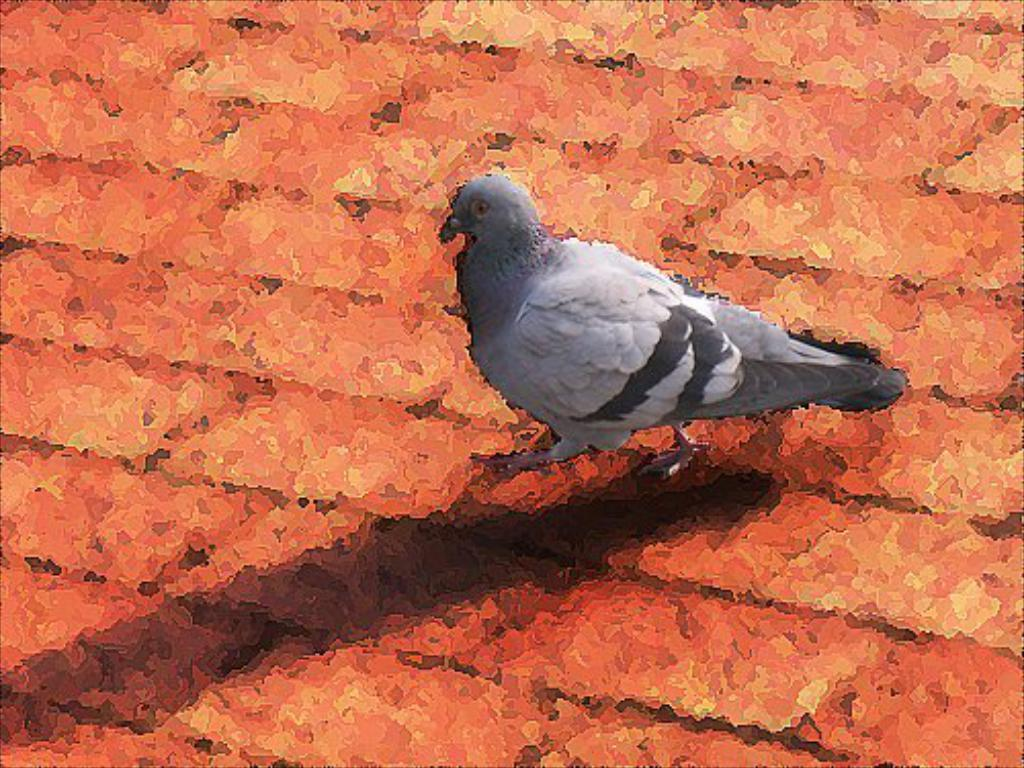What is the main subject of the image? There is a pigeon in the center of the image. Can you describe any other objects or features in the image? There is a red color object in the image. What type of flower is blooming near the pigeon's elbow in the image? There is no flower or elbow present in the image, as it features a pigeon and a red color object. 